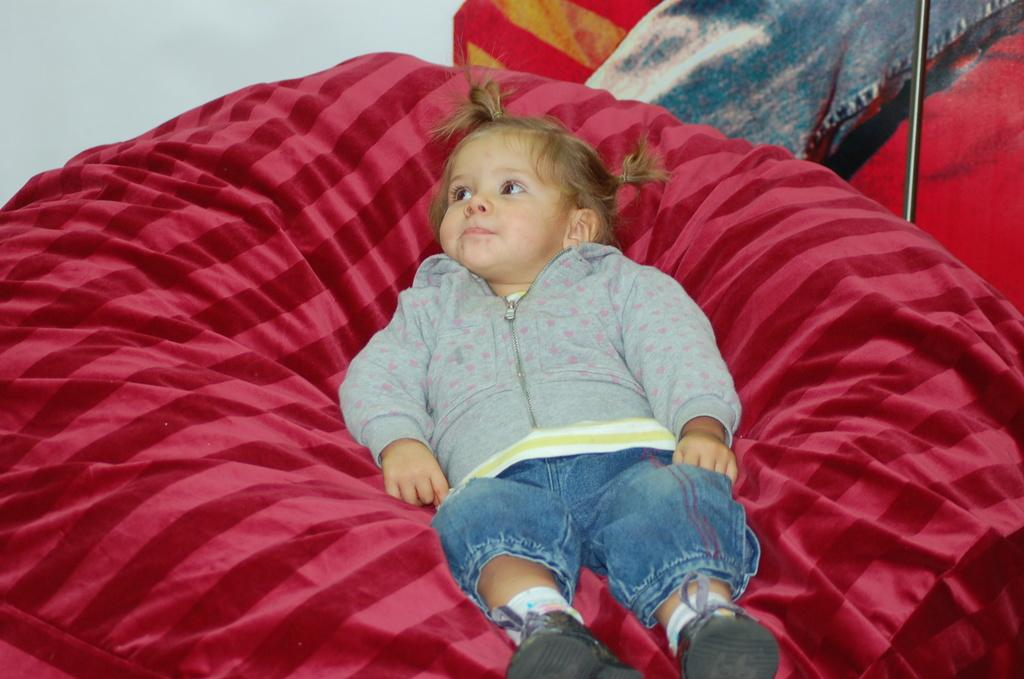Who is the main subject in the image? There is a baby girl in the image. What is the baby girl lying on? The baby girl is lying on a red color couch. Can you describe any other objects or features in the image? There is a rod beside the couch. What is the baby girl arguing about with the zebra in the image? There is no zebra present in the image, so there can be no argument between the baby girl and a zebra. 